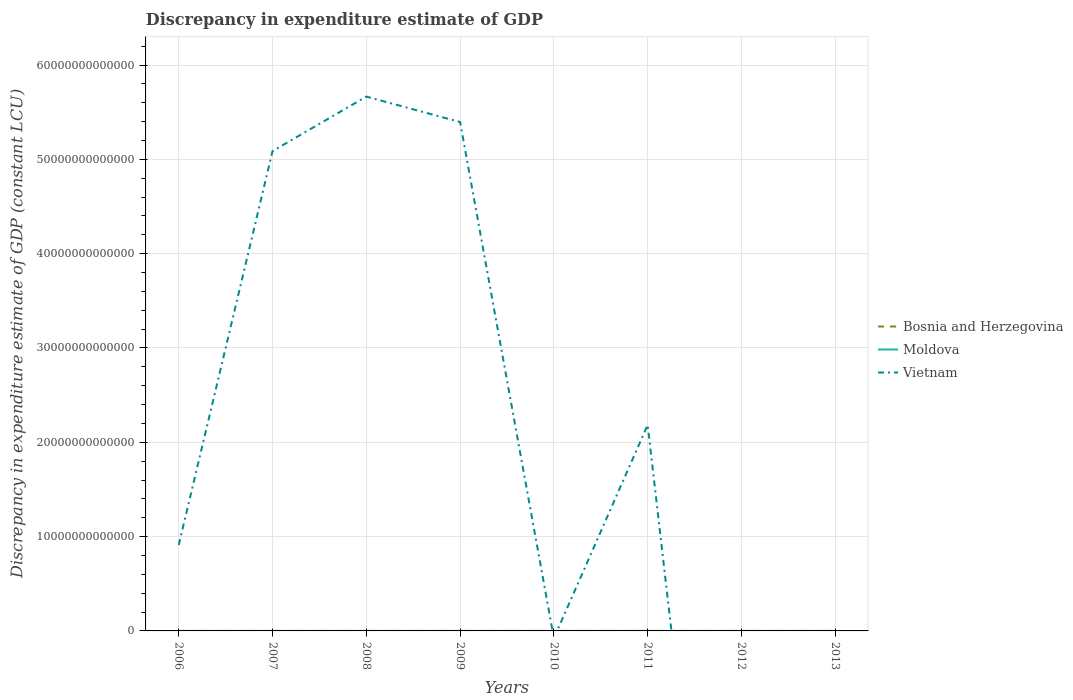How many different coloured lines are there?
Provide a succinct answer. 2. Does the line corresponding to Moldova intersect with the line corresponding to Bosnia and Herzegovina?
Make the answer very short. No. Is the number of lines equal to the number of legend labels?
Your answer should be very brief. No. What is the total discrepancy in expenditure estimate of GDP in Moldova in the graph?
Your answer should be compact. -1.78e+08. What is the difference between the highest and the second highest discrepancy in expenditure estimate of GDP in Vietnam?
Provide a short and direct response. 5.67e+13. Is the discrepancy in expenditure estimate of GDP in Moldova strictly greater than the discrepancy in expenditure estimate of GDP in Vietnam over the years?
Offer a very short reply. No. What is the difference between two consecutive major ticks on the Y-axis?
Your answer should be very brief. 1.00e+13. Are the values on the major ticks of Y-axis written in scientific E-notation?
Keep it short and to the point. No. Does the graph contain any zero values?
Offer a terse response. Yes. Does the graph contain grids?
Offer a terse response. Yes. What is the title of the graph?
Offer a terse response. Discrepancy in expenditure estimate of GDP. Does "Armenia" appear as one of the legend labels in the graph?
Your answer should be compact. No. What is the label or title of the X-axis?
Keep it short and to the point. Years. What is the label or title of the Y-axis?
Offer a terse response. Discrepancy in expenditure estimate of GDP (constant LCU). What is the Discrepancy in expenditure estimate of GDP (constant LCU) in Bosnia and Herzegovina in 2006?
Keep it short and to the point. 0. What is the Discrepancy in expenditure estimate of GDP (constant LCU) of Moldova in 2006?
Your answer should be very brief. 7.14e+05. What is the Discrepancy in expenditure estimate of GDP (constant LCU) of Vietnam in 2006?
Give a very brief answer. 9.12e+12. What is the Discrepancy in expenditure estimate of GDP (constant LCU) in Bosnia and Herzegovina in 2007?
Keep it short and to the point. 0. What is the Discrepancy in expenditure estimate of GDP (constant LCU) in Moldova in 2007?
Provide a succinct answer. 8.30e+05. What is the Discrepancy in expenditure estimate of GDP (constant LCU) in Vietnam in 2007?
Offer a terse response. 5.09e+13. What is the Discrepancy in expenditure estimate of GDP (constant LCU) in Bosnia and Herzegovina in 2008?
Your answer should be very brief. 0. What is the Discrepancy in expenditure estimate of GDP (constant LCU) in Moldova in 2008?
Provide a short and direct response. 0. What is the Discrepancy in expenditure estimate of GDP (constant LCU) of Vietnam in 2008?
Give a very brief answer. 5.67e+13. What is the Discrepancy in expenditure estimate of GDP (constant LCU) of Moldova in 2009?
Keep it short and to the point. 1.95e+05. What is the Discrepancy in expenditure estimate of GDP (constant LCU) in Vietnam in 2009?
Ensure brevity in your answer.  5.40e+13. What is the Discrepancy in expenditure estimate of GDP (constant LCU) of Moldova in 2010?
Your answer should be compact. 1.93e+05. What is the Discrepancy in expenditure estimate of GDP (constant LCU) of Vietnam in 2010?
Provide a succinct answer. 0. What is the Discrepancy in expenditure estimate of GDP (constant LCU) in Moldova in 2011?
Your response must be concise. 1.79e+08. What is the Discrepancy in expenditure estimate of GDP (constant LCU) in Vietnam in 2011?
Provide a succinct answer. 2.18e+13. What is the Discrepancy in expenditure estimate of GDP (constant LCU) of Vietnam in 2012?
Provide a succinct answer. 0. What is the Discrepancy in expenditure estimate of GDP (constant LCU) of Moldova in 2013?
Keep it short and to the point. 0. Across all years, what is the maximum Discrepancy in expenditure estimate of GDP (constant LCU) of Moldova?
Your answer should be very brief. 1.79e+08. Across all years, what is the maximum Discrepancy in expenditure estimate of GDP (constant LCU) in Vietnam?
Give a very brief answer. 5.67e+13. Across all years, what is the minimum Discrepancy in expenditure estimate of GDP (constant LCU) of Moldova?
Make the answer very short. 0. Across all years, what is the minimum Discrepancy in expenditure estimate of GDP (constant LCU) of Vietnam?
Offer a very short reply. 0. What is the total Discrepancy in expenditure estimate of GDP (constant LCU) in Bosnia and Herzegovina in the graph?
Your answer should be compact. 0. What is the total Discrepancy in expenditure estimate of GDP (constant LCU) of Moldova in the graph?
Your answer should be very brief. 1.81e+08. What is the total Discrepancy in expenditure estimate of GDP (constant LCU) in Vietnam in the graph?
Your answer should be very brief. 1.92e+14. What is the difference between the Discrepancy in expenditure estimate of GDP (constant LCU) in Moldova in 2006 and that in 2007?
Your answer should be very brief. -1.16e+05. What is the difference between the Discrepancy in expenditure estimate of GDP (constant LCU) of Vietnam in 2006 and that in 2007?
Make the answer very short. -4.18e+13. What is the difference between the Discrepancy in expenditure estimate of GDP (constant LCU) in Vietnam in 2006 and that in 2008?
Provide a short and direct response. -4.75e+13. What is the difference between the Discrepancy in expenditure estimate of GDP (constant LCU) in Moldova in 2006 and that in 2009?
Give a very brief answer. 5.20e+05. What is the difference between the Discrepancy in expenditure estimate of GDP (constant LCU) of Vietnam in 2006 and that in 2009?
Provide a short and direct response. -4.48e+13. What is the difference between the Discrepancy in expenditure estimate of GDP (constant LCU) in Moldova in 2006 and that in 2010?
Your answer should be very brief. 5.21e+05. What is the difference between the Discrepancy in expenditure estimate of GDP (constant LCU) in Moldova in 2006 and that in 2011?
Offer a very short reply. -1.78e+08. What is the difference between the Discrepancy in expenditure estimate of GDP (constant LCU) of Vietnam in 2006 and that in 2011?
Your answer should be very brief. -1.27e+13. What is the difference between the Discrepancy in expenditure estimate of GDP (constant LCU) in Vietnam in 2007 and that in 2008?
Make the answer very short. -5.78e+12. What is the difference between the Discrepancy in expenditure estimate of GDP (constant LCU) in Moldova in 2007 and that in 2009?
Provide a succinct answer. 6.35e+05. What is the difference between the Discrepancy in expenditure estimate of GDP (constant LCU) of Vietnam in 2007 and that in 2009?
Provide a short and direct response. -3.08e+12. What is the difference between the Discrepancy in expenditure estimate of GDP (constant LCU) in Moldova in 2007 and that in 2010?
Your response must be concise. 6.37e+05. What is the difference between the Discrepancy in expenditure estimate of GDP (constant LCU) of Moldova in 2007 and that in 2011?
Provide a succinct answer. -1.78e+08. What is the difference between the Discrepancy in expenditure estimate of GDP (constant LCU) of Vietnam in 2007 and that in 2011?
Make the answer very short. 2.90e+13. What is the difference between the Discrepancy in expenditure estimate of GDP (constant LCU) in Vietnam in 2008 and that in 2009?
Provide a short and direct response. 2.70e+12. What is the difference between the Discrepancy in expenditure estimate of GDP (constant LCU) of Vietnam in 2008 and that in 2011?
Give a very brief answer. 3.48e+13. What is the difference between the Discrepancy in expenditure estimate of GDP (constant LCU) of Moldova in 2009 and that in 2010?
Offer a very short reply. 1800. What is the difference between the Discrepancy in expenditure estimate of GDP (constant LCU) of Moldova in 2009 and that in 2011?
Ensure brevity in your answer.  -1.79e+08. What is the difference between the Discrepancy in expenditure estimate of GDP (constant LCU) in Vietnam in 2009 and that in 2011?
Your answer should be compact. 3.21e+13. What is the difference between the Discrepancy in expenditure estimate of GDP (constant LCU) of Moldova in 2010 and that in 2011?
Ensure brevity in your answer.  -1.79e+08. What is the difference between the Discrepancy in expenditure estimate of GDP (constant LCU) in Moldova in 2006 and the Discrepancy in expenditure estimate of GDP (constant LCU) in Vietnam in 2007?
Make the answer very short. -5.09e+13. What is the difference between the Discrepancy in expenditure estimate of GDP (constant LCU) of Moldova in 2006 and the Discrepancy in expenditure estimate of GDP (constant LCU) of Vietnam in 2008?
Keep it short and to the point. -5.67e+13. What is the difference between the Discrepancy in expenditure estimate of GDP (constant LCU) in Moldova in 2006 and the Discrepancy in expenditure estimate of GDP (constant LCU) in Vietnam in 2009?
Ensure brevity in your answer.  -5.40e+13. What is the difference between the Discrepancy in expenditure estimate of GDP (constant LCU) of Moldova in 2006 and the Discrepancy in expenditure estimate of GDP (constant LCU) of Vietnam in 2011?
Your answer should be very brief. -2.18e+13. What is the difference between the Discrepancy in expenditure estimate of GDP (constant LCU) of Moldova in 2007 and the Discrepancy in expenditure estimate of GDP (constant LCU) of Vietnam in 2008?
Provide a succinct answer. -5.67e+13. What is the difference between the Discrepancy in expenditure estimate of GDP (constant LCU) in Moldova in 2007 and the Discrepancy in expenditure estimate of GDP (constant LCU) in Vietnam in 2009?
Make the answer very short. -5.40e+13. What is the difference between the Discrepancy in expenditure estimate of GDP (constant LCU) in Moldova in 2007 and the Discrepancy in expenditure estimate of GDP (constant LCU) in Vietnam in 2011?
Give a very brief answer. -2.18e+13. What is the difference between the Discrepancy in expenditure estimate of GDP (constant LCU) of Moldova in 2009 and the Discrepancy in expenditure estimate of GDP (constant LCU) of Vietnam in 2011?
Give a very brief answer. -2.18e+13. What is the difference between the Discrepancy in expenditure estimate of GDP (constant LCU) of Moldova in 2010 and the Discrepancy in expenditure estimate of GDP (constant LCU) of Vietnam in 2011?
Provide a short and direct response. -2.18e+13. What is the average Discrepancy in expenditure estimate of GDP (constant LCU) in Bosnia and Herzegovina per year?
Your answer should be very brief. 0. What is the average Discrepancy in expenditure estimate of GDP (constant LCU) of Moldova per year?
Provide a succinct answer. 2.26e+07. What is the average Discrepancy in expenditure estimate of GDP (constant LCU) in Vietnam per year?
Give a very brief answer. 2.41e+13. In the year 2006, what is the difference between the Discrepancy in expenditure estimate of GDP (constant LCU) in Moldova and Discrepancy in expenditure estimate of GDP (constant LCU) in Vietnam?
Your answer should be compact. -9.11e+12. In the year 2007, what is the difference between the Discrepancy in expenditure estimate of GDP (constant LCU) in Moldova and Discrepancy in expenditure estimate of GDP (constant LCU) in Vietnam?
Ensure brevity in your answer.  -5.09e+13. In the year 2009, what is the difference between the Discrepancy in expenditure estimate of GDP (constant LCU) of Moldova and Discrepancy in expenditure estimate of GDP (constant LCU) of Vietnam?
Provide a short and direct response. -5.40e+13. In the year 2011, what is the difference between the Discrepancy in expenditure estimate of GDP (constant LCU) in Moldova and Discrepancy in expenditure estimate of GDP (constant LCU) in Vietnam?
Your answer should be very brief. -2.18e+13. What is the ratio of the Discrepancy in expenditure estimate of GDP (constant LCU) in Moldova in 2006 to that in 2007?
Ensure brevity in your answer.  0.86. What is the ratio of the Discrepancy in expenditure estimate of GDP (constant LCU) in Vietnam in 2006 to that in 2007?
Provide a short and direct response. 0.18. What is the ratio of the Discrepancy in expenditure estimate of GDP (constant LCU) of Vietnam in 2006 to that in 2008?
Offer a very short reply. 0.16. What is the ratio of the Discrepancy in expenditure estimate of GDP (constant LCU) in Moldova in 2006 to that in 2009?
Ensure brevity in your answer.  3.67. What is the ratio of the Discrepancy in expenditure estimate of GDP (constant LCU) of Vietnam in 2006 to that in 2009?
Provide a short and direct response. 0.17. What is the ratio of the Discrepancy in expenditure estimate of GDP (constant LCU) in Moldova in 2006 to that in 2010?
Keep it short and to the point. 3.7. What is the ratio of the Discrepancy in expenditure estimate of GDP (constant LCU) in Moldova in 2006 to that in 2011?
Offer a very short reply. 0. What is the ratio of the Discrepancy in expenditure estimate of GDP (constant LCU) of Vietnam in 2006 to that in 2011?
Your answer should be compact. 0.42. What is the ratio of the Discrepancy in expenditure estimate of GDP (constant LCU) of Vietnam in 2007 to that in 2008?
Your answer should be compact. 0.9. What is the ratio of the Discrepancy in expenditure estimate of GDP (constant LCU) in Moldova in 2007 to that in 2009?
Offer a terse response. 4.26. What is the ratio of the Discrepancy in expenditure estimate of GDP (constant LCU) of Vietnam in 2007 to that in 2009?
Offer a terse response. 0.94. What is the ratio of the Discrepancy in expenditure estimate of GDP (constant LCU) of Moldova in 2007 to that in 2010?
Keep it short and to the point. 4.3. What is the ratio of the Discrepancy in expenditure estimate of GDP (constant LCU) in Moldova in 2007 to that in 2011?
Provide a short and direct response. 0. What is the ratio of the Discrepancy in expenditure estimate of GDP (constant LCU) of Vietnam in 2007 to that in 2011?
Provide a succinct answer. 2.33. What is the ratio of the Discrepancy in expenditure estimate of GDP (constant LCU) in Vietnam in 2008 to that in 2011?
Keep it short and to the point. 2.59. What is the ratio of the Discrepancy in expenditure estimate of GDP (constant LCU) of Moldova in 2009 to that in 2010?
Make the answer very short. 1.01. What is the ratio of the Discrepancy in expenditure estimate of GDP (constant LCU) in Moldova in 2009 to that in 2011?
Your answer should be very brief. 0. What is the ratio of the Discrepancy in expenditure estimate of GDP (constant LCU) of Vietnam in 2009 to that in 2011?
Provide a short and direct response. 2.47. What is the ratio of the Discrepancy in expenditure estimate of GDP (constant LCU) of Moldova in 2010 to that in 2011?
Make the answer very short. 0. What is the difference between the highest and the second highest Discrepancy in expenditure estimate of GDP (constant LCU) of Moldova?
Offer a terse response. 1.78e+08. What is the difference between the highest and the second highest Discrepancy in expenditure estimate of GDP (constant LCU) of Vietnam?
Provide a short and direct response. 2.70e+12. What is the difference between the highest and the lowest Discrepancy in expenditure estimate of GDP (constant LCU) in Moldova?
Ensure brevity in your answer.  1.79e+08. What is the difference between the highest and the lowest Discrepancy in expenditure estimate of GDP (constant LCU) of Vietnam?
Your answer should be compact. 5.67e+13. 